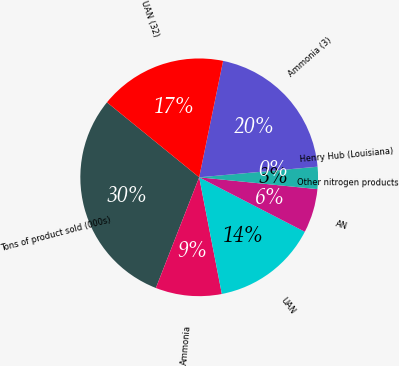Convert chart. <chart><loc_0><loc_0><loc_500><loc_500><pie_chart><fcel>Tons of product sold (000s)<fcel>Ammonia<fcel>UAN<fcel>AN<fcel>Other nitrogen products<fcel>Henry Hub (Louisiana)<fcel>Ammonia (3)<fcel>UAN (32)<nl><fcel>29.93%<fcel>8.99%<fcel>14.37%<fcel>5.99%<fcel>3.0%<fcel>0.01%<fcel>20.35%<fcel>17.36%<nl></chart> 